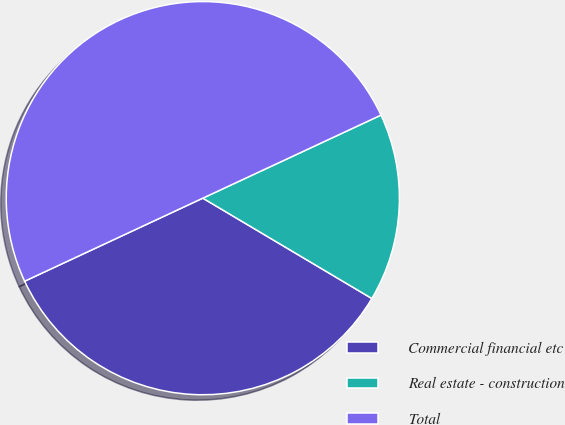Convert chart. <chart><loc_0><loc_0><loc_500><loc_500><pie_chart><fcel>Commercial financial etc<fcel>Real estate - construction<fcel>Total<nl><fcel>34.53%<fcel>15.47%<fcel>50.0%<nl></chart> 